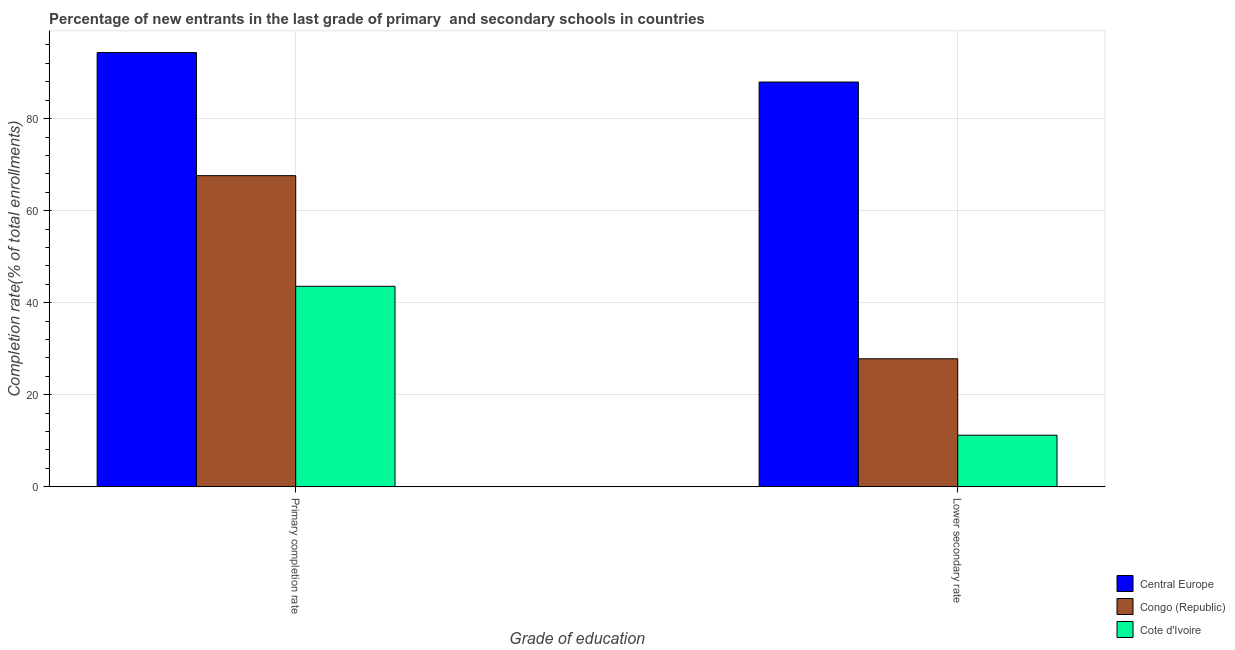How many different coloured bars are there?
Your answer should be compact. 3. Are the number of bars per tick equal to the number of legend labels?
Offer a very short reply. Yes. Are the number of bars on each tick of the X-axis equal?
Offer a terse response. Yes. How many bars are there on the 1st tick from the right?
Your answer should be compact. 3. What is the label of the 2nd group of bars from the left?
Your response must be concise. Lower secondary rate. What is the completion rate in secondary schools in Cote d'Ivoire?
Your response must be concise. 11.19. Across all countries, what is the maximum completion rate in primary schools?
Offer a very short reply. 94.36. Across all countries, what is the minimum completion rate in primary schools?
Give a very brief answer. 43.56. In which country was the completion rate in secondary schools maximum?
Give a very brief answer. Central Europe. In which country was the completion rate in primary schools minimum?
Your response must be concise. Cote d'Ivoire. What is the total completion rate in primary schools in the graph?
Your answer should be compact. 205.51. What is the difference between the completion rate in secondary schools in Congo (Republic) and that in Central Europe?
Offer a terse response. -60.14. What is the difference between the completion rate in secondary schools in Central Europe and the completion rate in primary schools in Cote d'Ivoire?
Offer a very short reply. 44.39. What is the average completion rate in secondary schools per country?
Provide a short and direct response. 42.32. What is the difference between the completion rate in primary schools and completion rate in secondary schools in Cote d'Ivoire?
Your answer should be compact. 32.36. What is the ratio of the completion rate in primary schools in Cote d'Ivoire to that in Congo (Republic)?
Your answer should be compact. 0.64. Is the completion rate in secondary schools in Cote d'Ivoire less than that in Congo (Republic)?
Your answer should be compact. Yes. In how many countries, is the completion rate in secondary schools greater than the average completion rate in secondary schools taken over all countries?
Provide a succinct answer. 1. What does the 2nd bar from the left in Primary completion rate represents?
Offer a very short reply. Congo (Republic). What does the 2nd bar from the right in Lower secondary rate represents?
Make the answer very short. Congo (Republic). Are all the bars in the graph horizontal?
Your answer should be very brief. No. How many countries are there in the graph?
Provide a succinct answer. 3. Does the graph contain any zero values?
Keep it short and to the point. No. How are the legend labels stacked?
Offer a terse response. Vertical. What is the title of the graph?
Offer a terse response. Percentage of new entrants in the last grade of primary  and secondary schools in countries. Does "Slovenia" appear as one of the legend labels in the graph?
Make the answer very short. No. What is the label or title of the X-axis?
Offer a very short reply. Grade of education. What is the label or title of the Y-axis?
Give a very brief answer. Completion rate(% of total enrollments). What is the Completion rate(% of total enrollments) of Central Europe in Primary completion rate?
Provide a short and direct response. 94.36. What is the Completion rate(% of total enrollments) in Congo (Republic) in Primary completion rate?
Your response must be concise. 67.6. What is the Completion rate(% of total enrollments) of Cote d'Ivoire in Primary completion rate?
Provide a short and direct response. 43.56. What is the Completion rate(% of total enrollments) in Central Europe in Lower secondary rate?
Your answer should be compact. 87.95. What is the Completion rate(% of total enrollments) in Congo (Republic) in Lower secondary rate?
Provide a succinct answer. 27.81. What is the Completion rate(% of total enrollments) of Cote d'Ivoire in Lower secondary rate?
Keep it short and to the point. 11.19. Across all Grade of education, what is the maximum Completion rate(% of total enrollments) in Central Europe?
Keep it short and to the point. 94.36. Across all Grade of education, what is the maximum Completion rate(% of total enrollments) of Congo (Republic)?
Your answer should be very brief. 67.6. Across all Grade of education, what is the maximum Completion rate(% of total enrollments) of Cote d'Ivoire?
Keep it short and to the point. 43.56. Across all Grade of education, what is the minimum Completion rate(% of total enrollments) of Central Europe?
Provide a short and direct response. 87.95. Across all Grade of education, what is the minimum Completion rate(% of total enrollments) in Congo (Republic)?
Your answer should be very brief. 27.81. Across all Grade of education, what is the minimum Completion rate(% of total enrollments) in Cote d'Ivoire?
Ensure brevity in your answer.  11.19. What is the total Completion rate(% of total enrollments) in Central Europe in the graph?
Your answer should be compact. 182.3. What is the total Completion rate(% of total enrollments) of Congo (Republic) in the graph?
Ensure brevity in your answer.  95.41. What is the total Completion rate(% of total enrollments) in Cote d'Ivoire in the graph?
Offer a very short reply. 54.75. What is the difference between the Completion rate(% of total enrollments) in Central Europe in Primary completion rate and that in Lower secondary rate?
Your response must be concise. 6.41. What is the difference between the Completion rate(% of total enrollments) in Congo (Republic) in Primary completion rate and that in Lower secondary rate?
Give a very brief answer. 39.79. What is the difference between the Completion rate(% of total enrollments) of Cote d'Ivoire in Primary completion rate and that in Lower secondary rate?
Ensure brevity in your answer.  32.36. What is the difference between the Completion rate(% of total enrollments) in Central Europe in Primary completion rate and the Completion rate(% of total enrollments) in Congo (Republic) in Lower secondary rate?
Keep it short and to the point. 66.55. What is the difference between the Completion rate(% of total enrollments) of Central Europe in Primary completion rate and the Completion rate(% of total enrollments) of Cote d'Ivoire in Lower secondary rate?
Offer a very short reply. 83.16. What is the difference between the Completion rate(% of total enrollments) of Congo (Republic) in Primary completion rate and the Completion rate(% of total enrollments) of Cote d'Ivoire in Lower secondary rate?
Your answer should be compact. 56.41. What is the average Completion rate(% of total enrollments) in Central Europe per Grade of education?
Offer a very short reply. 91.15. What is the average Completion rate(% of total enrollments) of Congo (Republic) per Grade of education?
Give a very brief answer. 47.7. What is the average Completion rate(% of total enrollments) in Cote d'Ivoire per Grade of education?
Your response must be concise. 27.38. What is the difference between the Completion rate(% of total enrollments) of Central Europe and Completion rate(% of total enrollments) of Congo (Republic) in Primary completion rate?
Your answer should be compact. 26.76. What is the difference between the Completion rate(% of total enrollments) of Central Europe and Completion rate(% of total enrollments) of Cote d'Ivoire in Primary completion rate?
Your answer should be very brief. 50.8. What is the difference between the Completion rate(% of total enrollments) in Congo (Republic) and Completion rate(% of total enrollments) in Cote d'Ivoire in Primary completion rate?
Your answer should be very brief. 24.04. What is the difference between the Completion rate(% of total enrollments) in Central Europe and Completion rate(% of total enrollments) in Congo (Republic) in Lower secondary rate?
Your answer should be very brief. 60.14. What is the difference between the Completion rate(% of total enrollments) in Central Europe and Completion rate(% of total enrollments) in Cote d'Ivoire in Lower secondary rate?
Provide a succinct answer. 76.75. What is the difference between the Completion rate(% of total enrollments) of Congo (Republic) and Completion rate(% of total enrollments) of Cote d'Ivoire in Lower secondary rate?
Offer a very short reply. 16.61. What is the ratio of the Completion rate(% of total enrollments) in Central Europe in Primary completion rate to that in Lower secondary rate?
Offer a terse response. 1.07. What is the ratio of the Completion rate(% of total enrollments) of Congo (Republic) in Primary completion rate to that in Lower secondary rate?
Offer a terse response. 2.43. What is the ratio of the Completion rate(% of total enrollments) of Cote d'Ivoire in Primary completion rate to that in Lower secondary rate?
Provide a succinct answer. 3.89. What is the difference between the highest and the second highest Completion rate(% of total enrollments) of Central Europe?
Give a very brief answer. 6.41. What is the difference between the highest and the second highest Completion rate(% of total enrollments) of Congo (Republic)?
Keep it short and to the point. 39.79. What is the difference between the highest and the second highest Completion rate(% of total enrollments) in Cote d'Ivoire?
Provide a succinct answer. 32.36. What is the difference between the highest and the lowest Completion rate(% of total enrollments) of Central Europe?
Offer a terse response. 6.41. What is the difference between the highest and the lowest Completion rate(% of total enrollments) of Congo (Republic)?
Provide a short and direct response. 39.79. What is the difference between the highest and the lowest Completion rate(% of total enrollments) in Cote d'Ivoire?
Your answer should be compact. 32.36. 